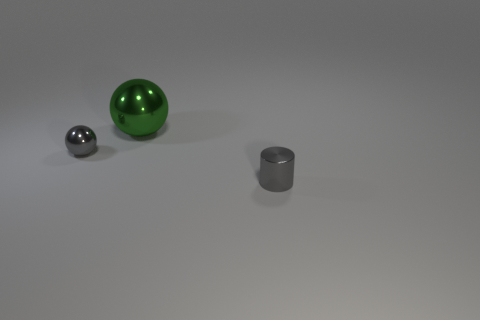Add 1 tiny objects. How many objects exist? 4 Subtract all cylinders. How many objects are left? 2 Add 3 tiny cylinders. How many tiny cylinders exist? 4 Subtract 0 yellow balls. How many objects are left? 3 Subtract all metal things. Subtract all small cyan cylinders. How many objects are left? 0 Add 3 metallic things. How many metallic things are left? 6 